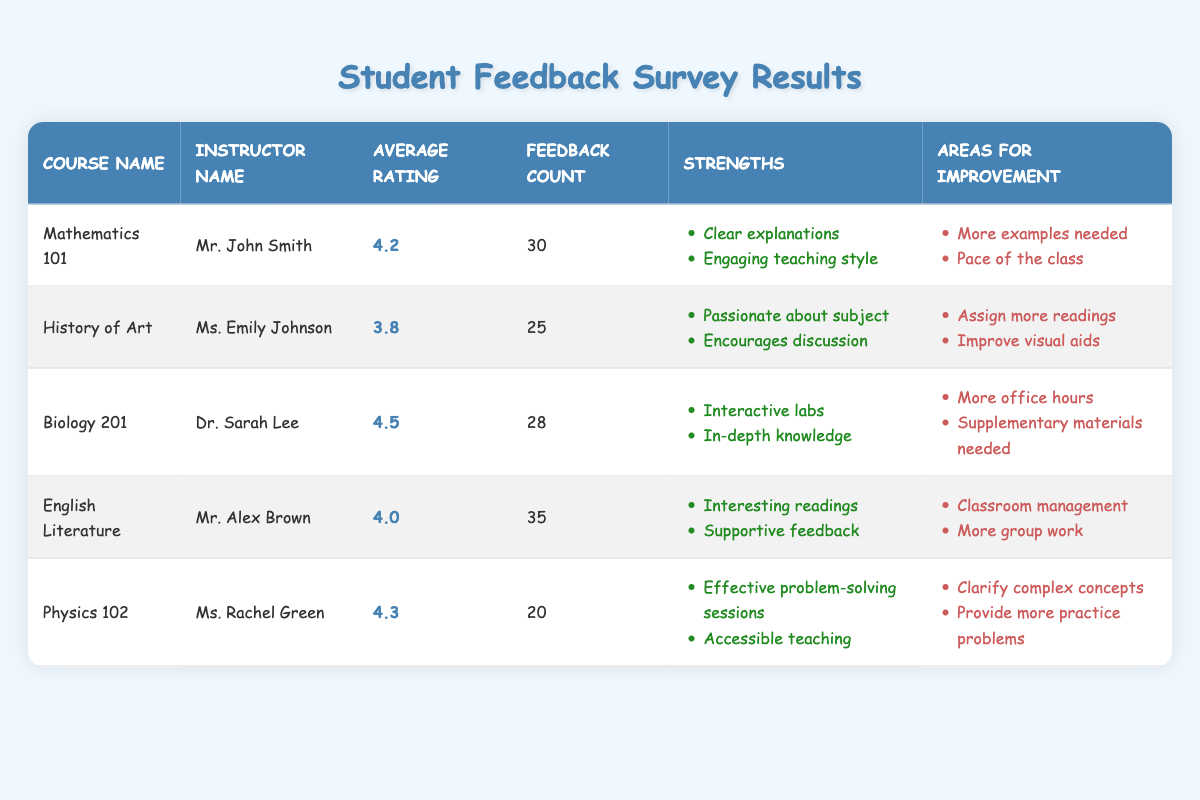What is the average rating for Mathematics 101? The table lists the average rating for Mathematics 101 as 4.2.
Answer: 4.2 How many feedback responses did Dr. Sarah Lee receive for Biology 201? According to the table, Dr. Sarah Lee received 28 feedback responses for Biology 201.
Answer: 28 Which course had the highest average rating? The table shows that Biology 201 has the highest average rating of 4.5 among all the courses listed.
Answer: 4.5 What are the strengths of Mr. Alex Brown’s course? Based on the table, the strengths of Mr. Alex Brown's course, English Literature, include "Interesting readings" and "Supportive feedback."
Answer: Interesting readings, Supportive feedback Did Ms. Rachel Green receive more feedback responses than Ms. Emily Johnson? The table shows that Ms. Rachel Green received 20 feedback responses, while Ms. Emily Johnson received 25 feedback responses, so Ms. Rachel Green did not receive more.
Answer: No What is the total feedback count for all instructors combined? To find the total feedback count, we sum the feedback counts for each course: 30 + 25 + 28 + 35 + 20 = 168. Therefore, the total feedback count is 168.
Answer: 168 For which instructor was improving classroom management suggested as an area for improvement? The table indicates that "Classroom management" is an area for improvement for Mr. Alex Brown, the instructor for English Literature.
Answer: Mr. Alex Brown What is the average rating for courses with more than 30 feedback responses? The courses with more than 30 feedback responses are Mathematics 101 (4.2) and English Literature (4.0). We calculate the average: (4.2 + 4.0) / 2 = 4.1.
Answer: 4.1 Are there any instructors who received an average rating below 4.0? Yes, Ms. Emily Johnson received an average rating of 3.8 for the History of Art course, which is below 4.0.
Answer: Yes 